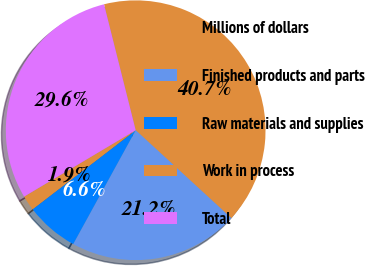<chart> <loc_0><loc_0><loc_500><loc_500><pie_chart><fcel>Millions of dollars<fcel>Finished products and parts<fcel>Raw materials and supplies<fcel>Work in process<fcel>Total<nl><fcel>40.75%<fcel>21.16%<fcel>6.6%<fcel>1.87%<fcel>29.62%<nl></chart> 